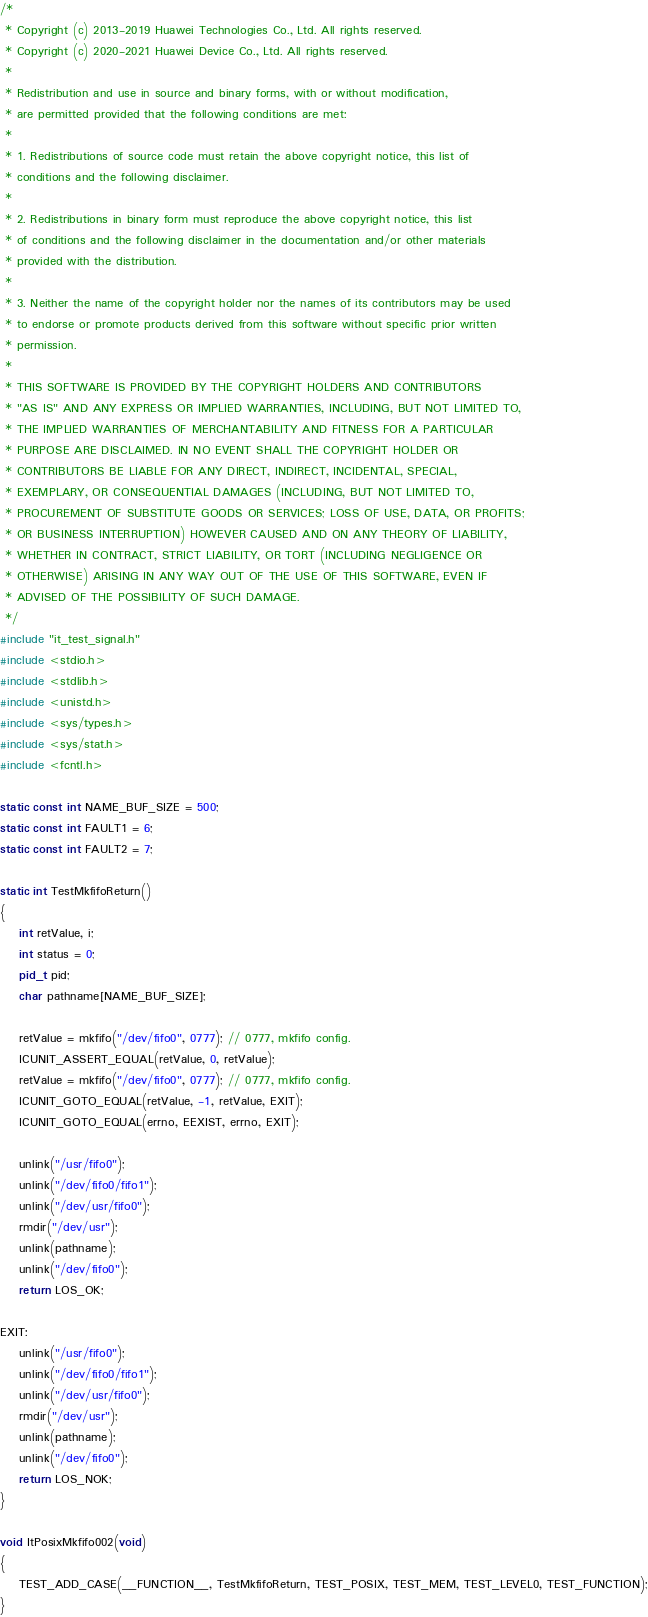<code> <loc_0><loc_0><loc_500><loc_500><_C++_>/*
 * Copyright (c) 2013-2019 Huawei Technologies Co., Ltd. All rights reserved.
 * Copyright (c) 2020-2021 Huawei Device Co., Ltd. All rights reserved.
 *
 * Redistribution and use in source and binary forms, with or without modification,
 * are permitted provided that the following conditions are met:
 *
 * 1. Redistributions of source code must retain the above copyright notice, this list of
 * conditions and the following disclaimer.
 *
 * 2. Redistributions in binary form must reproduce the above copyright notice, this list
 * of conditions and the following disclaimer in the documentation and/or other materials
 * provided with the distribution.
 *
 * 3. Neither the name of the copyright holder nor the names of its contributors may be used
 * to endorse or promote products derived from this software without specific prior written
 * permission.
 *
 * THIS SOFTWARE IS PROVIDED BY THE COPYRIGHT HOLDERS AND CONTRIBUTORS
 * "AS IS" AND ANY EXPRESS OR IMPLIED WARRANTIES, INCLUDING, BUT NOT LIMITED TO,
 * THE IMPLIED WARRANTIES OF MERCHANTABILITY AND FITNESS FOR A PARTICULAR
 * PURPOSE ARE DISCLAIMED. IN NO EVENT SHALL THE COPYRIGHT HOLDER OR
 * CONTRIBUTORS BE LIABLE FOR ANY DIRECT, INDIRECT, INCIDENTAL, SPECIAL,
 * EXEMPLARY, OR CONSEQUENTIAL DAMAGES (INCLUDING, BUT NOT LIMITED TO,
 * PROCUREMENT OF SUBSTITUTE GOODS OR SERVICES; LOSS OF USE, DATA, OR PROFITS;
 * OR BUSINESS INTERRUPTION) HOWEVER CAUSED AND ON ANY THEORY OF LIABILITY,
 * WHETHER IN CONTRACT, STRICT LIABILITY, OR TORT (INCLUDING NEGLIGENCE OR
 * OTHERWISE) ARISING IN ANY WAY OUT OF THE USE OF THIS SOFTWARE, EVEN IF
 * ADVISED OF THE POSSIBILITY OF SUCH DAMAGE.
 */
#include "it_test_signal.h"
#include <stdio.h>
#include <stdlib.h>
#include <unistd.h>
#include <sys/types.h>
#include <sys/stat.h>
#include <fcntl.h>

static const int NAME_BUF_SIZE = 500;
static const int FAULT1 = 6;
static const int FAULT2 = 7;

static int TestMkfifoReturn()
{
    int retValue, i;
    int status = 0;
    pid_t pid;
    char pathname[NAME_BUF_SIZE];

    retValue = mkfifo("/dev/fifo0", 0777); // 0777, mkfifo config.
    ICUNIT_ASSERT_EQUAL(retValue, 0, retValue);
    retValue = mkfifo("/dev/fifo0", 0777); // 0777, mkfifo config.
    ICUNIT_GOTO_EQUAL(retValue, -1, retValue, EXIT);
    ICUNIT_GOTO_EQUAL(errno, EEXIST, errno, EXIT);

    unlink("/usr/fifo0");
    unlink("/dev/fifo0/fifo1");
    unlink("/dev/usr/fifo0");
    rmdir("/dev/usr");
    unlink(pathname);
    unlink("/dev/fifo0");
    return LOS_OK;

EXIT:
    unlink("/usr/fifo0");
    unlink("/dev/fifo0/fifo1");
    unlink("/dev/usr/fifo0");
    rmdir("/dev/usr");
    unlink(pathname);
    unlink("/dev/fifo0");
    return LOS_NOK;
}

void ItPosixMkfifo002(void)
{
    TEST_ADD_CASE(__FUNCTION__, TestMkfifoReturn, TEST_POSIX, TEST_MEM, TEST_LEVEL0, TEST_FUNCTION);
}
</code> 